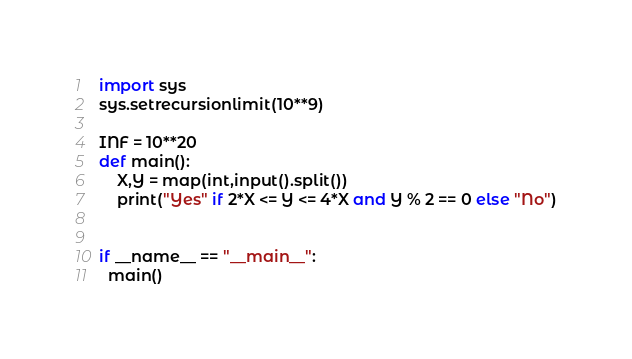Convert code to text. <code><loc_0><loc_0><loc_500><loc_500><_Python_>import sys
sys.setrecursionlimit(10**9)

INF = 10**20
def main():
    X,Y = map(int,input().split())
    print("Yes" if 2*X <= Y <= 4*X and Y % 2 == 0 else "No")


if __name__ == "__main__":
  main()
</code> 